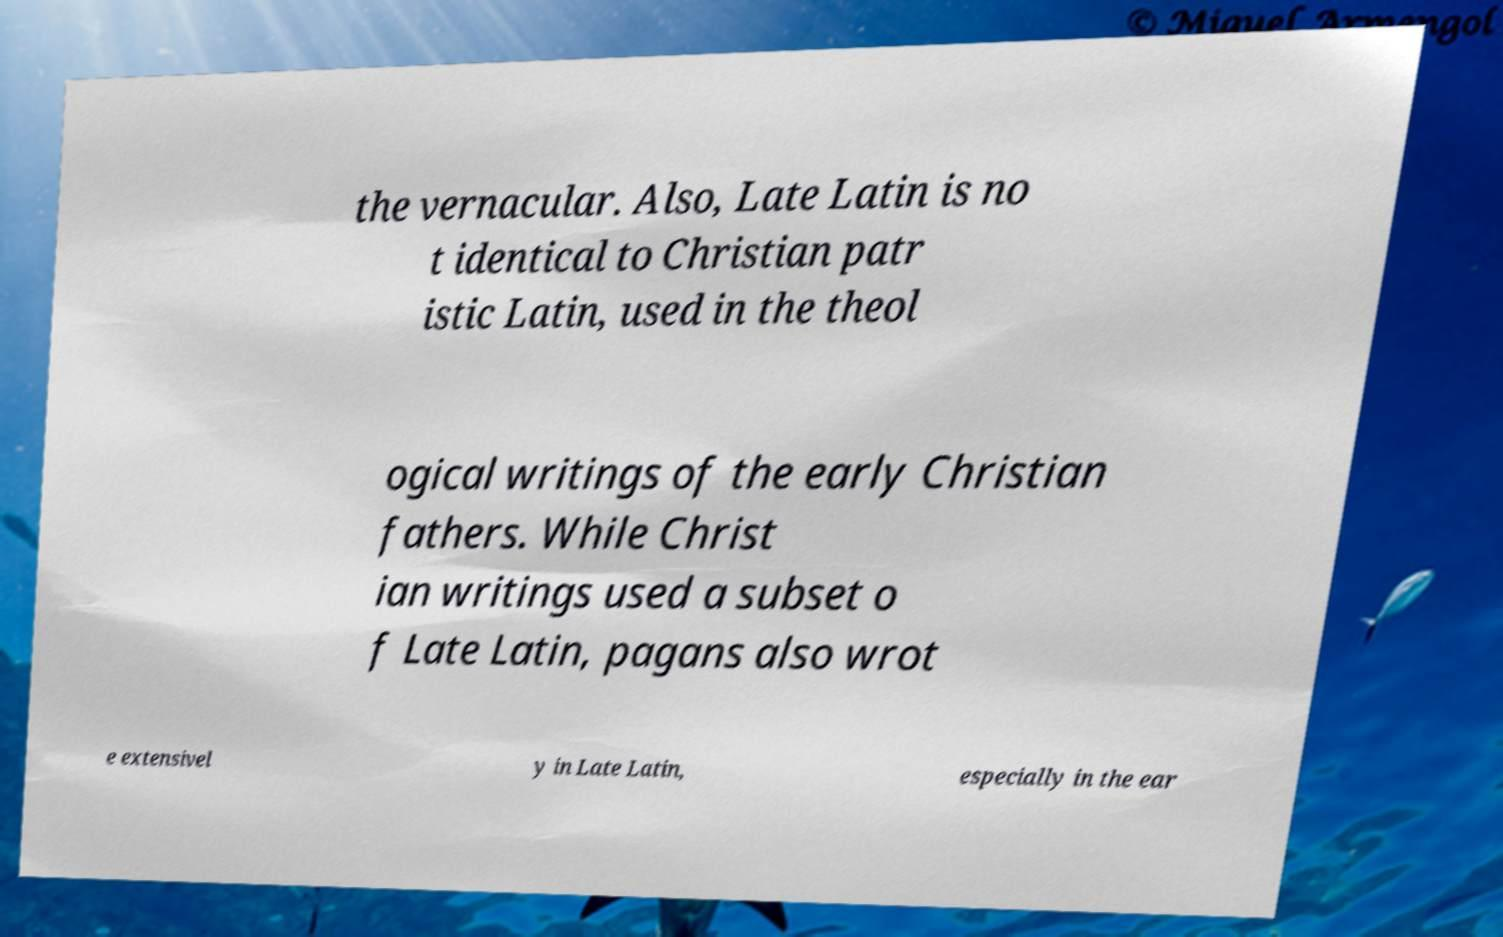For documentation purposes, I need the text within this image transcribed. Could you provide that? the vernacular. Also, Late Latin is no t identical to Christian patr istic Latin, used in the theol ogical writings of the early Christian fathers. While Christ ian writings used a subset o f Late Latin, pagans also wrot e extensivel y in Late Latin, especially in the ear 